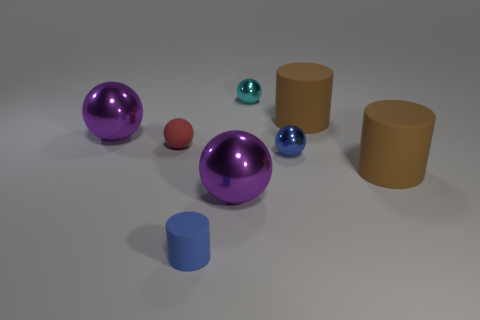Subtract 1 spheres. How many spheres are left? 4 Subtract all small blue metallic balls. How many balls are left? 4 Subtract all red balls. How many balls are left? 4 Subtract all brown spheres. Subtract all gray cylinders. How many spheres are left? 5 Add 1 tiny blue objects. How many objects exist? 9 Subtract all cylinders. How many objects are left? 5 Subtract all small brown metallic objects. Subtract all rubber objects. How many objects are left? 4 Add 3 rubber spheres. How many rubber spheres are left? 4 Add 5 big purple metal things. How many big purple metal things exist? 7 Subtract 0 green blocks. How many objects are left? 8 